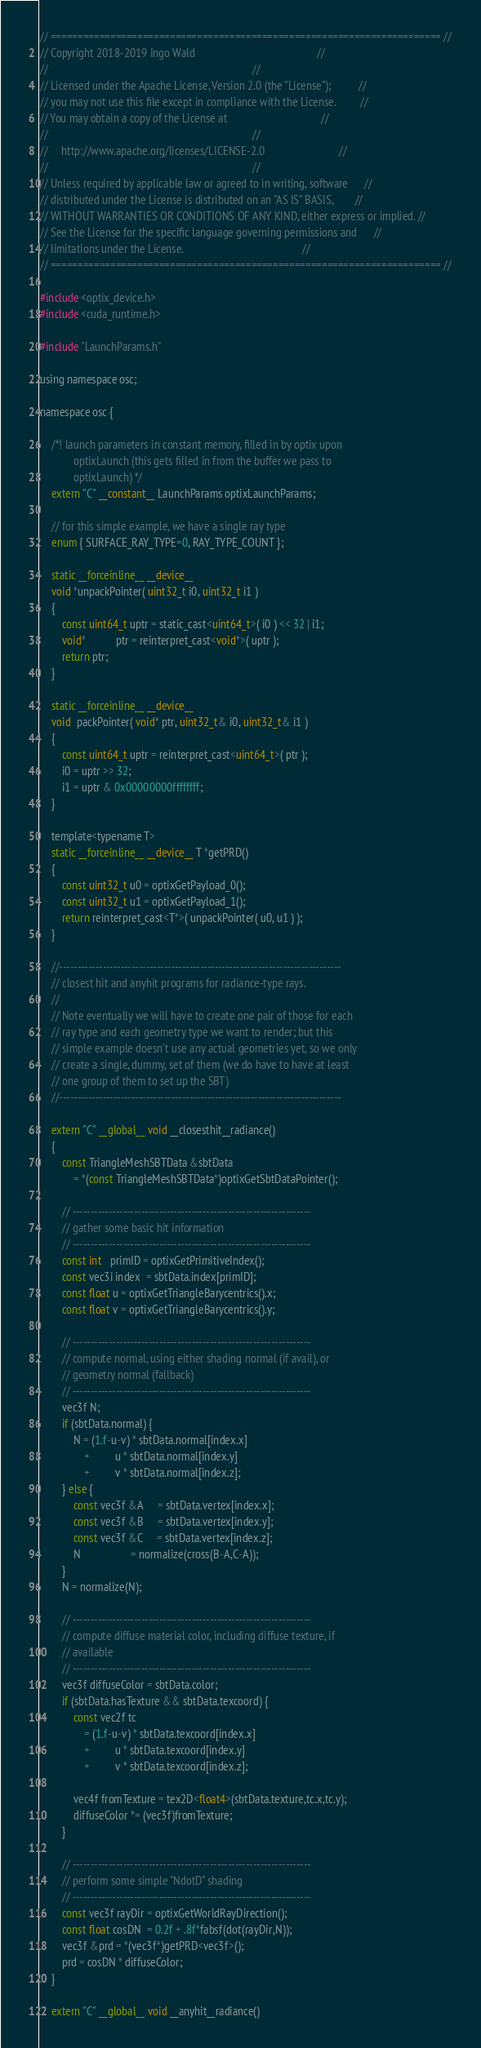<code> <loc_0><loc_0><loc_500><loc_500><_Cuda_>// ======================================================================== //
// Copyright 2018-2019 Ingo Wald                                            //
//                                                                          //
// Licensed under the Apache License, Version 2.0 (the "License");          //
// you may not use this file except in compliance with the License.         //
// You may obtain a copy of the License at                                  //
//                                                                          //
//     http://www.apache.org/licenses/LICENSE-2.0                           //
//                                                                          //
// Unless required by applicable law or agreed to in writing, software      //
// distributed under the License is distributed on an "AS IS" BASIS,        //
// WITHOUT WARRANTIES OR CONDITIONS OF ANY KIND, either express or implied. //
// See the License for the specific language governing permissions and      //
// limitations under the License.                                           //
// ======================================================================== //

#include <optix_device.h>
#include <cuda_runtime.h>

#include "LaunchParams.h"

using namespace osc;

namespace osc {
	
	/*! launch parameters in constant memory, filled in by optix upon
			optixLaunch (this gets filled in from the buffer we pass to
			optixLaunch) */
	extern "C" __constant__ LaunchParams optixLaunchParams;

	// for this simple example, we have a single ray type
	enum { SURFACE_RAY_TYPE=0, RAY_TYPE_COUNT };
	
	static __forceinline__ __device__
	void *unpackPointer( uint32_t i0, uint32_t i1 )
	{
		const uint64_t uptr = static_cast<uint64_t>( i0 ) << 32 | i1;
		void*           ptr = reinterpret_cast<void*>( uptr ); 
		return ptr;
	}

	static __forceinline__ __device__
	void  packPointer( void* ptr, uint32_t& i0, uint32_t& i1 )
	{
		const uint64_t uptr = reinterpret_cast<uint64_t>( ptr );
		i0 = uptr >> 32;
		i1 = uptr & 0x00000000ffffffff;
	}

	template<typename T>
	static __forceinline__ __device__ T *getPRD()
	{ 
		const uint32_t u0 = optixGetPayload_0();
		const uint32_t u1 = optixGetPayload_1();
		return reinterpret_cast<T*>( unpackPointer( u0, u1 ) );
	}
	
	//------------------------------------------------------------------------------
	// closest hit and anyhit programs for radiance-type rays.
	//
	// Note eventually we will have to create one pair of those for each
	// ray type and each geometry type we want to render; but this
	// simple example doesn't use any actual geometries yet, so we only
	// create a single, dummy, set of them (we do have to have at least
	// one group of them to set up the SBT)
	//------------------------------------------------------------------------------
	
	extern "C" __global__ void __closesthit__radiance()
	{
		const TriangleMeshSBTData &sbtData
			= *(const TriangleMeshSBTData*)optixGetSbtDataPointer();
		
		// ------------------------------------------------------------------
		// gather some basic hit information
		// ------------------------------------------------------------------
		const int   primID = optixGetPrimitiveIndex();
		const vec3i index  = sbtData.index[primID];
		const float u = optixGetTriangleBarycentrics().x;
		const float v = optixGetTriangleBarycentrics().y;

		// ------------------------------------------------------------------
		// compute normal, using either shading normal (if avail), or
		// geometry normal (fallback)
		// ------------------------------------------------------------------
		vec3f N;
		if (sbtData.normal) {
			N = (1.f-u-v) * sbtData.normal[index.x]
				+         u * sbtData.normal[index.y]
				+         v * sbtData.normal[index.z];
		} else {
			const vec3f &A     = sbtData.vertex[index.x];
			const vec3f &B     = sbtData.vertex[index.y];
			const vec3f &C     = sbtData.vertex[index.z];
			N                  = normalize(cross(B-A,C-A));
		}
		N = normalize(N);

		// ------------------------------------------------------------------
		// compute diffuse material color, including diffuse texture, if
		// available
		// ------------------------------------------------------------------
		vec3f diffuseColor = sbtData.color;
		if (sbtData.hasTexture && sbtData.texcoord) {
			const vec2f tc
				= (1.f-u-v) * sbtData.texcoord[index.x]
				+         u * sbtData.texcoord[index.y]
				+         v * sbtData.texcoord[index.z];
			
			vec4f fromTexture = tex2D<float4>(sbtData.texture,tc.x,tc.y);
			diffuseColor *= (vec3f)fromTexture;
		}
		
		// ------------------------------------------------------------------
		// perform some simple "NdotD" shading
		// ------------------------------------------------------------------
		const vec3f rayDir = optixGetWorldRayDirection();
		const float cosDN  = 0.2f + .8f*fabsf(dot(rayDir,N));
		vec3f &prd = *(vec3f*)getPRD<vec3f>();
		prd = cosDN * diffuseColor;
	}
	
	extern "C" __global__ void __anyhit__radiance()</code> 